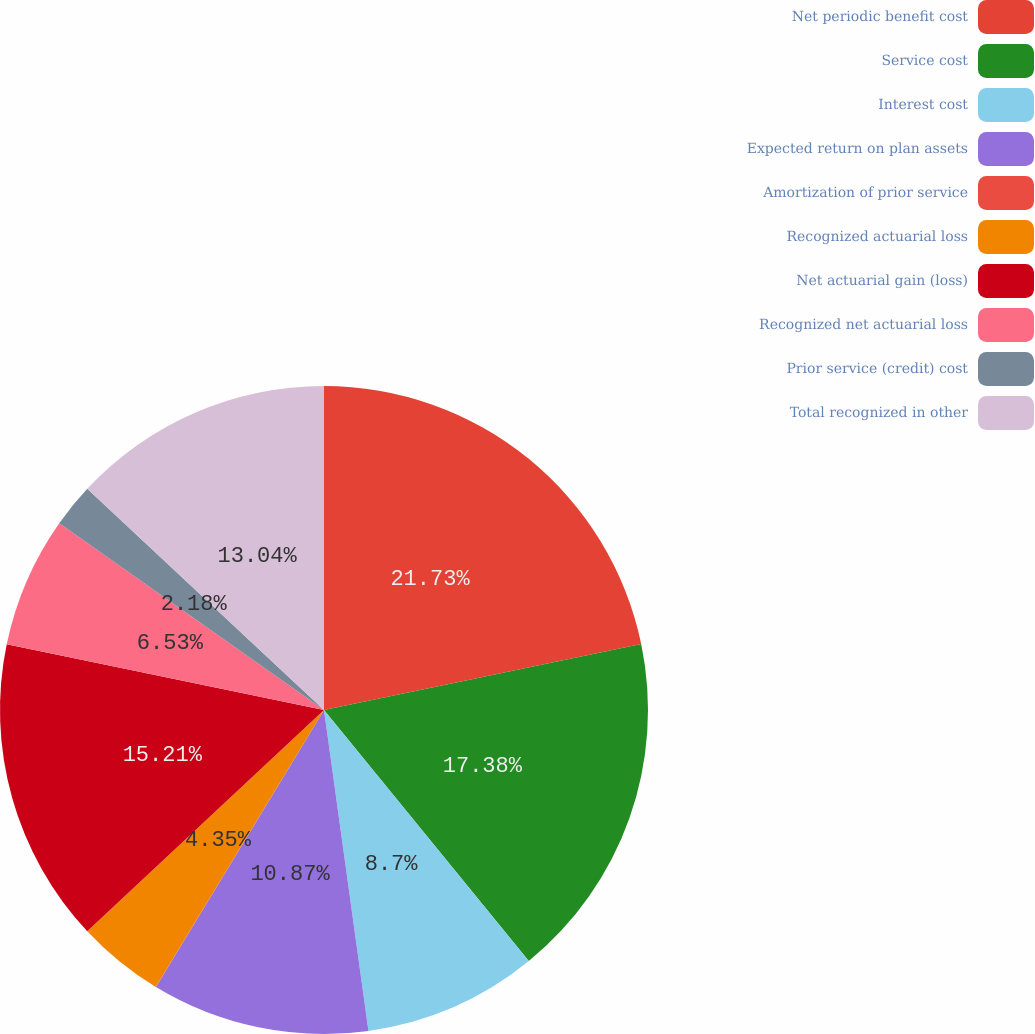Convert chart. <chart><loc_0><loc_0><loc_500><loc_500><pie_chart><fcel>Net periodic benefit cost<fcel>Service cost<fcel>Interest cost<fcel>Expected return on plan assets<fcel>Amortization of prior service<fcel>Recognized actuarial loss<fcel>Net actuarial gain (loss)<fcel>Recognized net actuarial loss<fcel>Prior service (credit) cost<fcel>Total recognized in other<nl><fcel>21.73%<fcel>17.38%<fcel>8.7%<fcel>10.87%<fcel>0.01%<fcel>4.35%<fcel>15.21%<fcel>6.53%<fcel>2.18%<fcel>13.04%<nl></chart> 